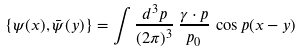Convert formula to latex. <formula><loc_0><loc_0><loc_500><loc_500>\left \{ \psi ( x ) , \bar { \psi } ( y ) \right \} = \int { \frac { d ^ { 3 } p } { ( 2 \pi ) ^ { 3 } } \, \frac { \gamma \cdot p } { p _ { 0 } } \, \cos p ( x - y ) }</formula> 